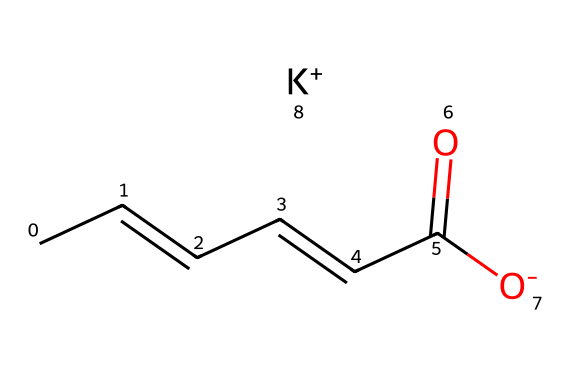What is the molecular formula of potassium sorbate? The chemical's structure can be broken down by identifying the components. The structure given corresponds to potassium sorbate, which contains carbon, hydrogen, oxygen, and potassium. The count of each atom leads us to the molecular formula, which is C6H7O2K.
Answer: C6H7O2K How many double bonds are present in potassium sorbate? Observing the structure shows there are two distinct double bonds located within the carbon chain. Each '/C=C/' signifies a double bond, leading to a total count of two.
Answer: 2 What is the significance of the carboxylate group in this molecule? The presence of the carboxylate group (−C(=O)[O−]) indicates the acidic property of the molecule, which is important for its preservative function as it can inhibit microbial growth.
Answer: preservative function What type of chemical is potassium sorbate classified as? Given the presence of an organic acid (specifically from the carboxylate group) and its use as a food preservative, potassium sorbate is classified as a food preservative.
Answer: food preservative Which atom in the structure indicates its function as a preservative? The carboxylate group (−C(=O)[O−]) contains the oxygen atoms and contributes to the biochemical activities that inhibit spoilage, making it essential for its preservative action.
Answer: carboxylate group How many carbon atoms does potassium sorbate have? By counting the carbon atoms within the provided structure, we find there are six carbon atoms represented in total.
Answer: 6 